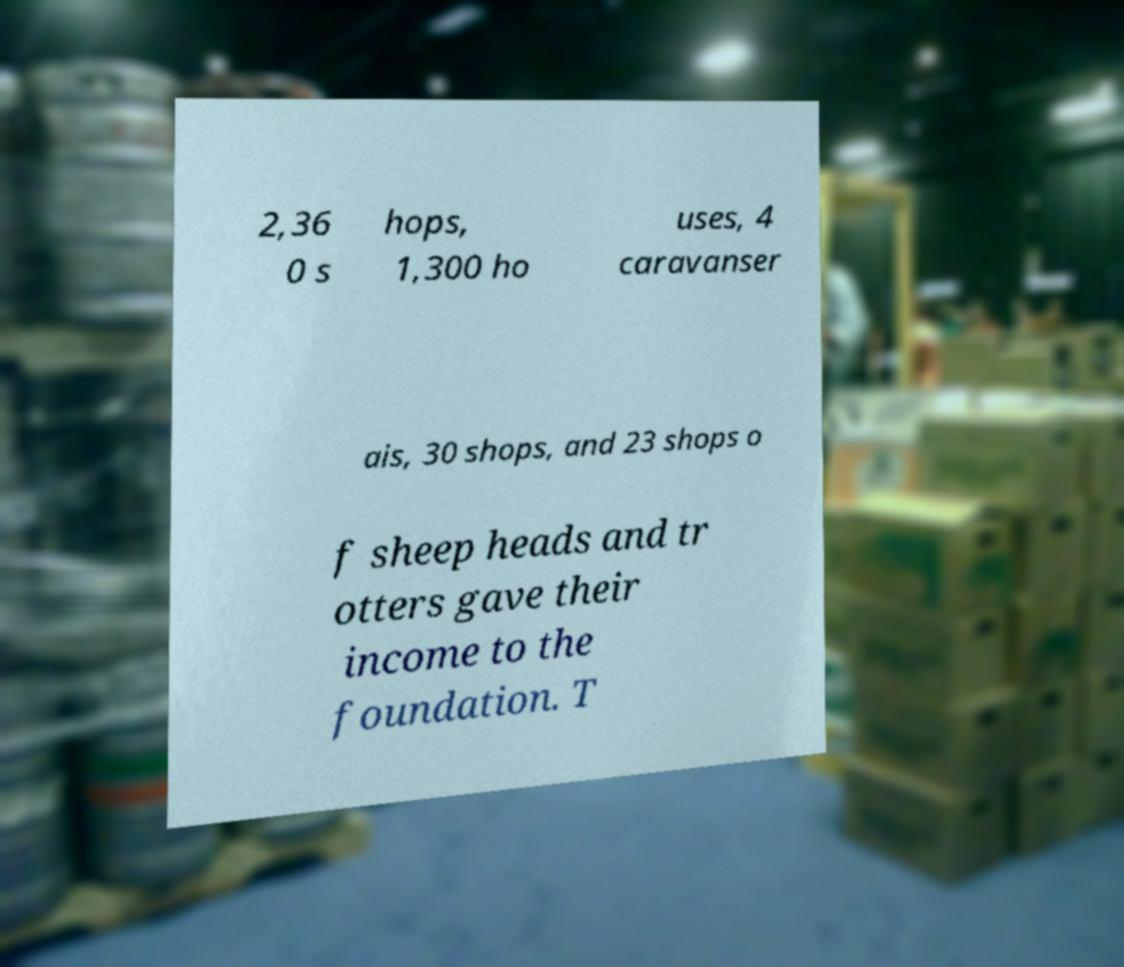There's text embedded in this image that I need extracted. Can you transcribe it verbatim? 2,36 0 s hops, 1,300 ho uses, 4 caravanser ais, 30 shops, and 23 shops o f sheep heads and tr otters gave their income to the foundation. T 